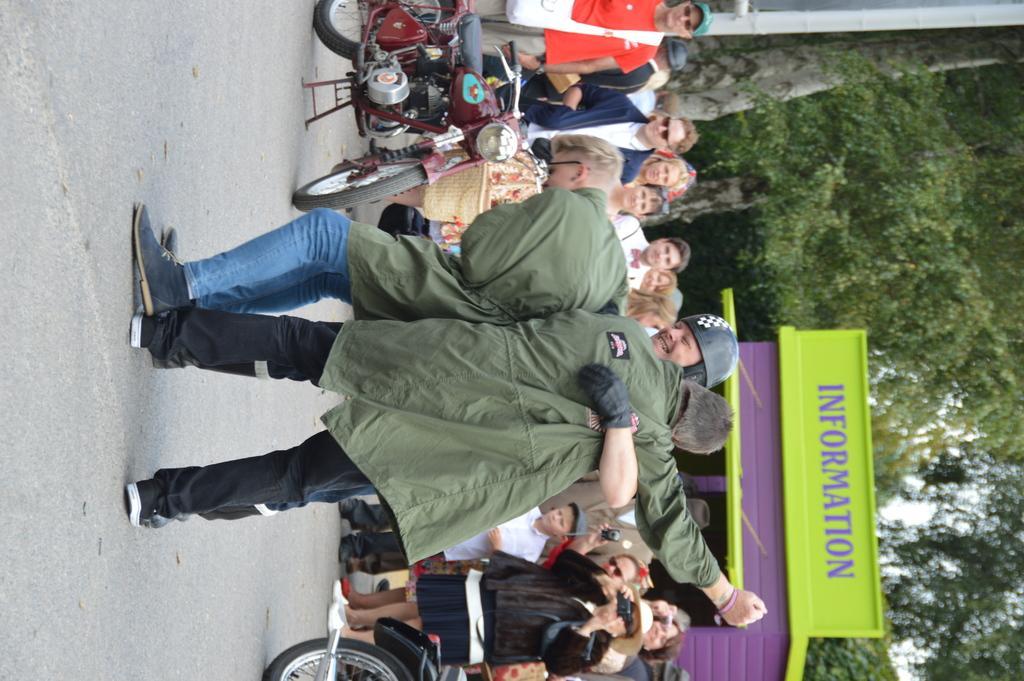Please provide a concise description of this image. In this picture we can see a few people are performing on the road, back side so many people are standing and watching. 